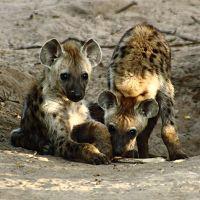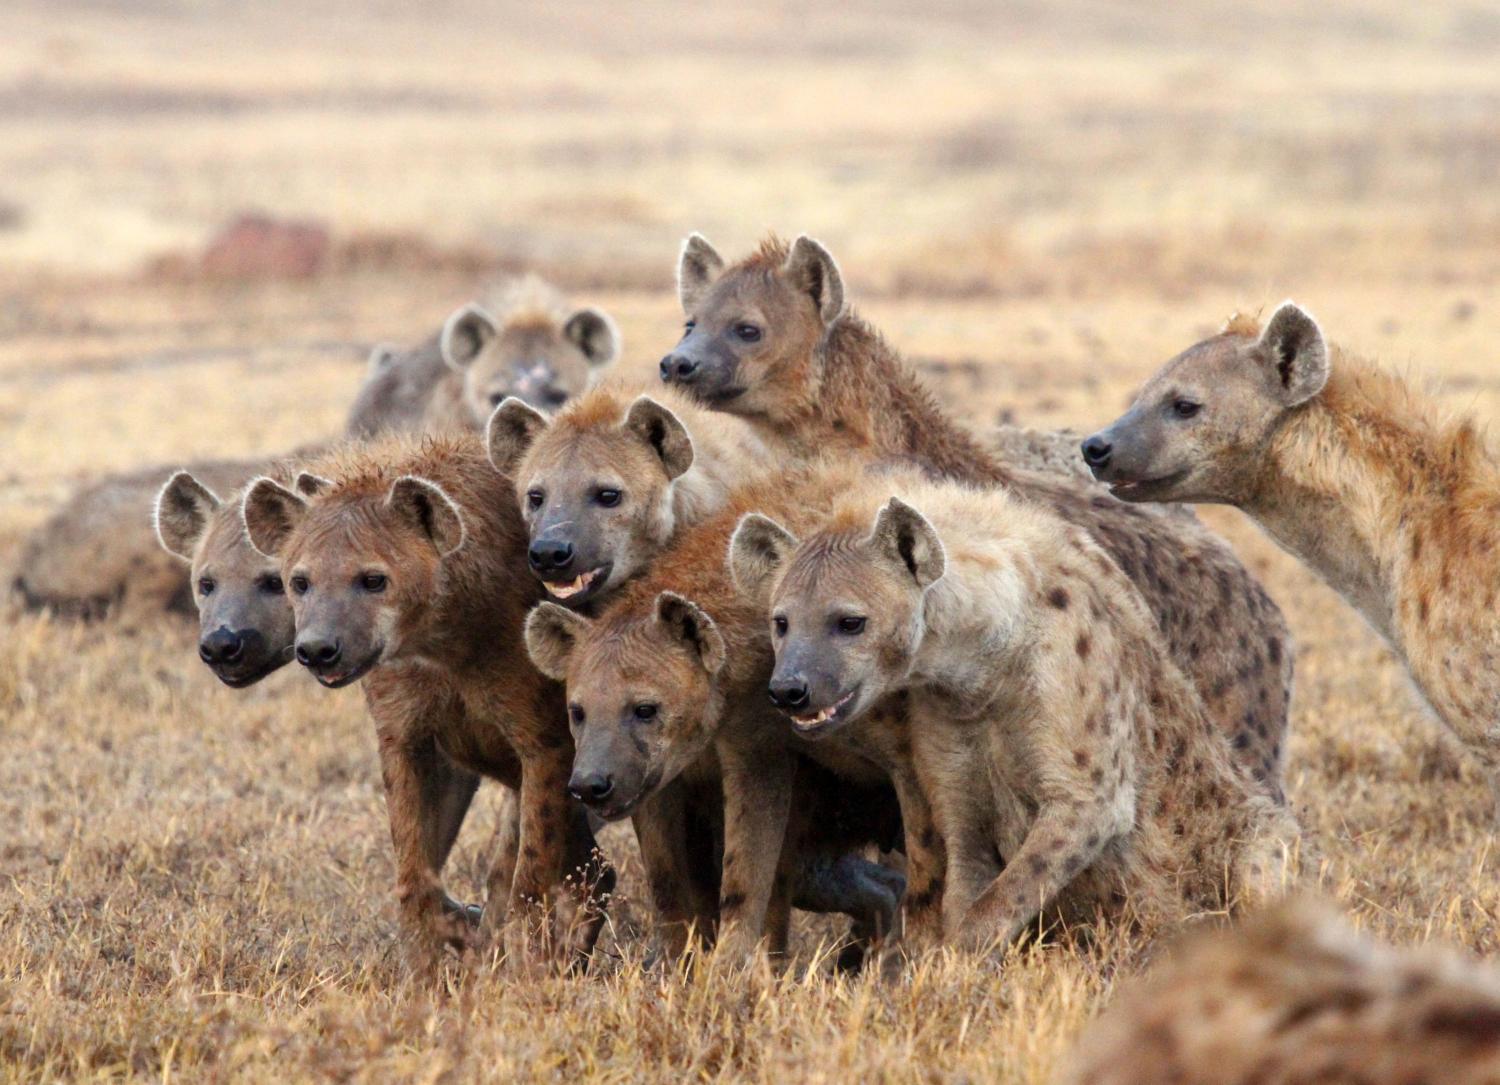The first image is the image on the left, the second image is the image on the right. Considering the images on both sides, is "In at least one image there is a single hyena with an open mouth showing its teeth." valid? Answer yes or no. No. The first image is the image on the left, the second image is the image on the right. Examine the images to the left and right. Is the description "There are only two hyenas." accurate? Answer yes or no. No. 